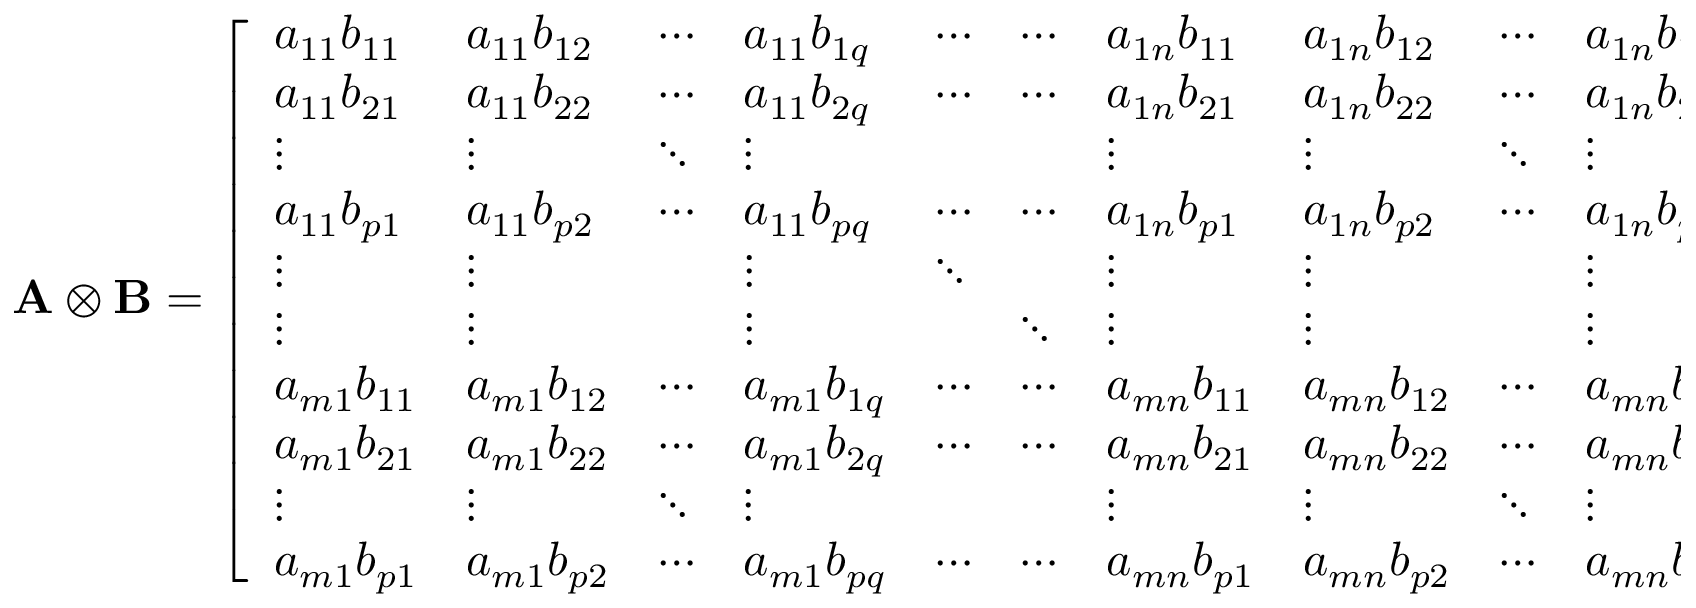Convert formula to latex. <formula><loc_0><loc_0><loc_500><loc_500>{ A \otimes B } = { \left [ \begin{array} { l l l l l l l l l l } { a _ { 1 1 } b _ { 1 1 } } & { a _ { 1 1 } b _ { 1 2 } } & { \cdots } & { a _ { 1 1 } b _ { 1 q } } & { \cdots } & { \cdots } & { a _ { 1 n } b _ { 1 1 } } & { a _ { 1 n } b _ { 1 2 } } & { \cdots } & { a _ { 1 n } b _ { 1 q } } \\ { a _ { 1 1 } b _ { 2 1 } } & { a _ { 1 1 } b _ { 2 2 } } & { \cdots } & { a _ { 1 1 } b _ { 2 q } } & { \cdots } & { \cdots } & { a _ { 1 n } b _ { 2 1 } } & { a _ { 1 n } b _ { 2 2 } } & { \cdots } & { a _ { 1 n } b _ { 2 q } } \\ { \vdots } & { \vdots } & { \ddots } & { \vdots } & { \vdots } & { \vdots } & { \ddots } & { \vdots } \\ { a _ { 1 1 } b _ { p 1 } } & { a _ { 1 1 } b _ { p 2 } } & { \cdots } & { a _ { 1 1 } b _ { p q } } & { \cdots } & { \cdots } & { a _ { 1 n } b _ { p 1 } } & { a _ { 1 n } b _ { p 2 } } & { \cdots } & { a _ { 1 n } b _ { p q } } \\ { \vdots } & { \vdots } & { \vdots } & { \ddots } & { \vdots } & { \vdots } & { \vdots } \\ { \vdots } & { \vdots } & { \vdots } & { \ddots } & { \vdots } & { \vdots } & { \vdots } \\ { a _ { m 1 } b _ { 1 1 } } & { a _ { m 1 } b _ { 1 2 } } & { \cdots } & { a _ { m 1 } b _ { 1 q } } & { \cdots } & { \cdots } & { a _ { m n } b _ { 1 1 } } & { a _ { m n } b _ { 1 2 } } & { \cdots } & { a _ { m n } b _ { 1 q } } \\ { a _ { m 1 } b _ { 2 1 } } & { a _ { m 1 } b _ { 2 2 } } & { \cdots } & { a _ { m 1 } b _ { 2 q } } & { \cdots } & { \cdots } & { a _ { m n } b _ { 2 1 } } & { a _ { m n } b _ { 2 2 } } & { \cdots } & { a _ { m n } b _ { 2 q } } \\ { \vdots } & { \vdots } & { \ddots } & { \vdots } & { \vdots } & { \vdots } & { \ddots } & { \vdots } \\ { a _ { m 1 } b _ { p 1 } } & { a _ { m 1 } b _ { p 2 } } & { \cdots } & { a _ { m 1 } b _ { p q } } & { \cdots } & { \cdots } & { a _ { m n } b _ { p 1 } } & { a _ { m n } b _ { p 2 } } & { \cdots } & { a _ { m n } b _ { p q } } \end{array} \right ] } .</formula> 